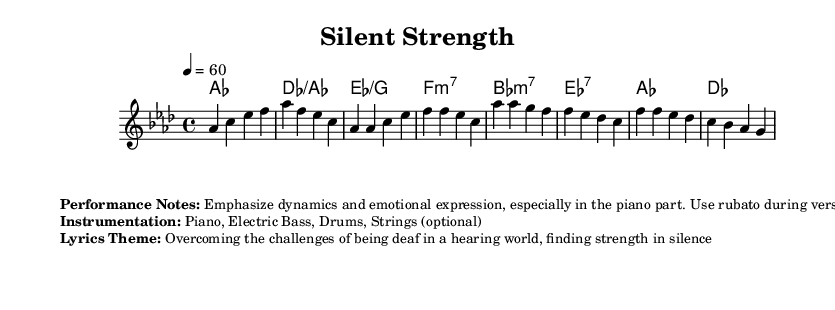What is the key signature of this music? The key signature is marked as A-flat major, which has four flats.
Answer: A-flat major What is the time signature of this music? The time signature is indicated as 4/4, meaning there are four beats in each measure and a quarter note receives one beat.
Answer: 4/4 What is the tempo marking for this piece? The tempo marking indicates that the piece should be played at a speed of 60 beats per minute.
Answer: 60 How many measures are shown in the melody? Counting the measures in the melody section, there are a total of 8 measures present in the provided snippet.
Answer: 8 What is the theme of the lyrics in this music? The lyrics theme focuses on overcoming the challenges of being deaf in a hearing world, emphasizing the inner strength found in silence.
Answer: Overcoming challenges of being deaf Which instruments are suggested for this music? The suggested instrumentation includes piano, electric bass, drums, and optionally, strings.
Answer: Piano, Electric Bass, Drums, Strings What chord follows the first melody note? The first melody note ('A-flat') is accompanied by the chord A-flat major, which confirms the harmony structure at the beginning.
Answer: A-flat major 